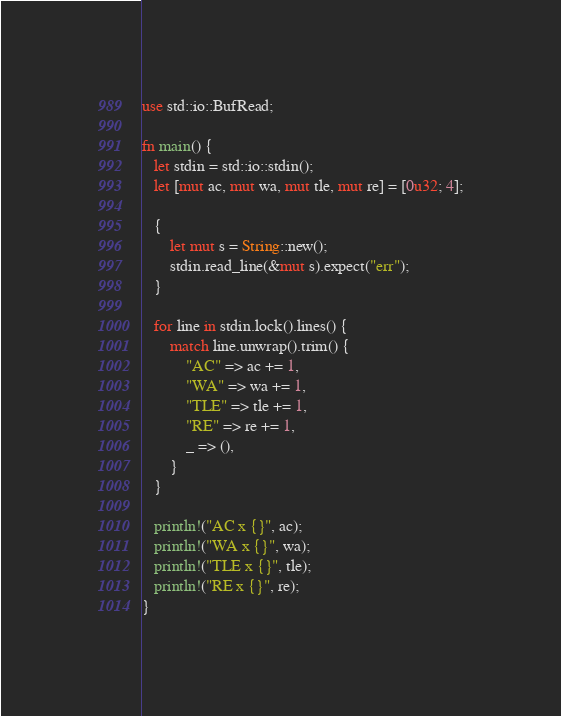<code> <loc_0><loc_0><loc_500><loc_500><_Rust_>use std::io::BufRead;

fn main() {
   let stdin = std::io::stdin();
   let [mut ac, mut wa, mut tle, mut re] = [0u32; 4];

   {
       let mut s = String::new();
       stdin.read_line(&mut s).expect("err");
   }

   for line in stdin.lock().lines() {
       match line.unwrap().trim() {
           "AC" => ac += 1,
           "WA" => wa += 1,
           "TLE" => tle += 1,
           "RE" => re += 1,
           _ => (),
       }
   }

   println!("AC x {}", ac);
   println!("WA x {}", wa);
   println!("TLE x {}", tle);
   println!("RE x {}", re);
}
</code> 